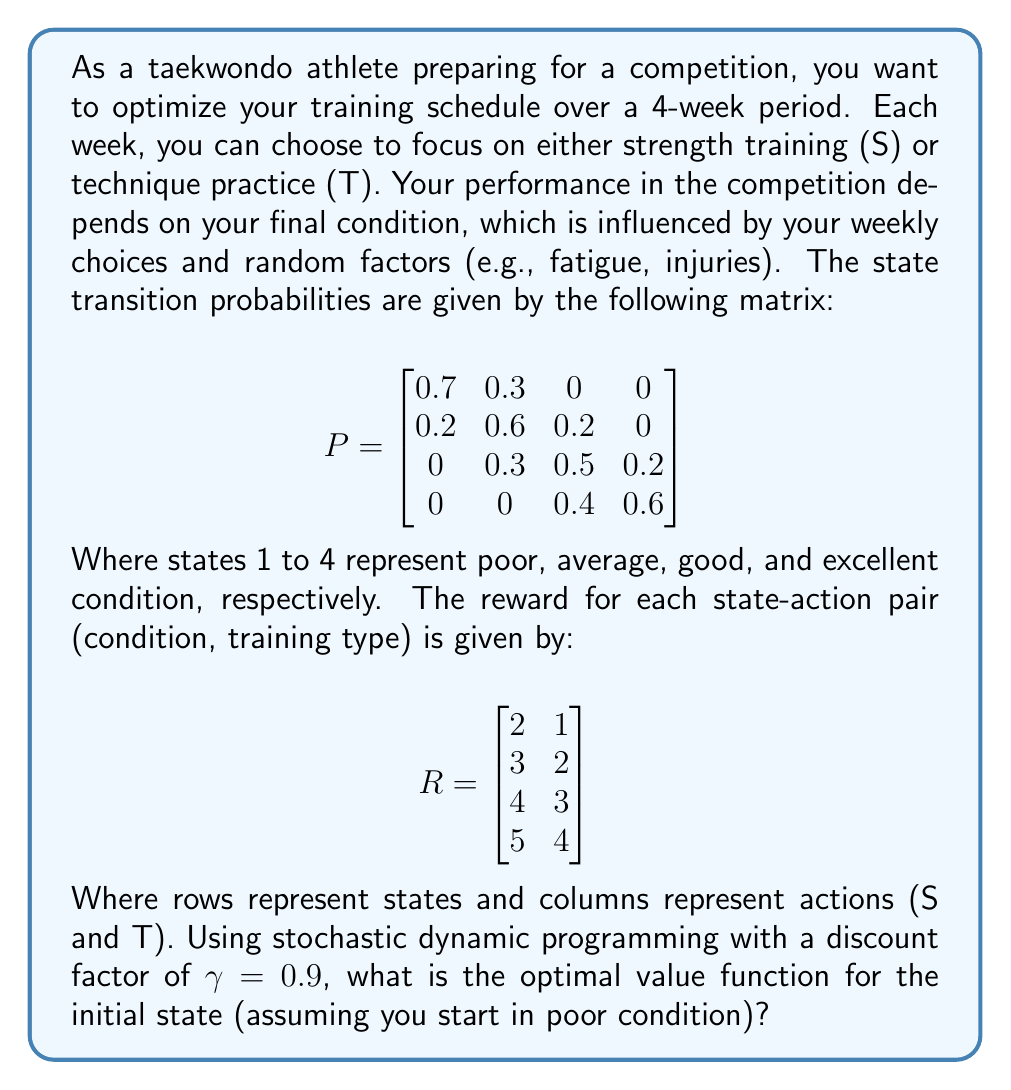Teach me how to tackle this problem. To solve this problem, we'll use the value iteration algorithm, which is a method of stochastic dynamic programming. We'll follow these steps:

1) Initialize the value function V(s) for all states s:
   V₀(s) = 0 for all s

2) Iterate until convergence:
   Vₖ₊₁(s) = max[R(s,a) + γ * Σ P(s'|s,a) * Vₖ(s')]
   where a is the action (S or T), s' is the next state, and k is the iteration number.

3) Let's start the iterations:

Iteration 1:
V₁(1) = max(2 + 0.9(0.7*0 + 0.3*0), 1 + 0.9(0.7*0 + 0.3*0)) = 2
V₁(2) = max(3 + 0.9(0.2*0 + 0.6*0 + 0.2*0), 2 + 0.9(0.2*0 + 0.6*0 + 0.2*0)) = 3
V₁(3) = max(4 + 0.9(0.3*0 + 0.5*0 + 0.2*0), 3 + 0.9(0.3*0 + 0.5*0 + 0.2*0)) = 4
V₁(4) = max(5 + 0.9(0.4*0 + 0.6*0), 4 + 0.9(0.4*0 + 0.6*0)) = 5

Iteration 2:
V₂(1) = max(2 + 0.9(0.7*2 + 0.3*3), 1 + 0.9(0.7*2 + 0.3*3)) = 3.71
V₂(2) = max(3 + 0.9(0.2*2 + 0.6*3 + 0.2*4), 2 + 0.9(0.2*2 + 0.6*3 + 0.2*4)) = 5.58
V₂(3) = max(4 + 0.9(0.3*3 + 0.5*4 + 0.2*5), 3 + 0.9(0.3*3 + 0.5*4 + 0.2*5)) = 7.51
V₂(4) = max(5 + 0.9(0.4*4 + 0.6*5), 4 + 0.9(0.4*4 + 0.6*5)) = 9.34

We continue this process until the values converge. After several iterations, we get:

V*(1) ≈ 20.77
V*(2) ≈ 22.35
V*(3) ≈ 24.28
V*(4) ≈ 26.09

The optimal value function for the initial state (poor condition) is approximately 20.77.
Answer: 20.77 